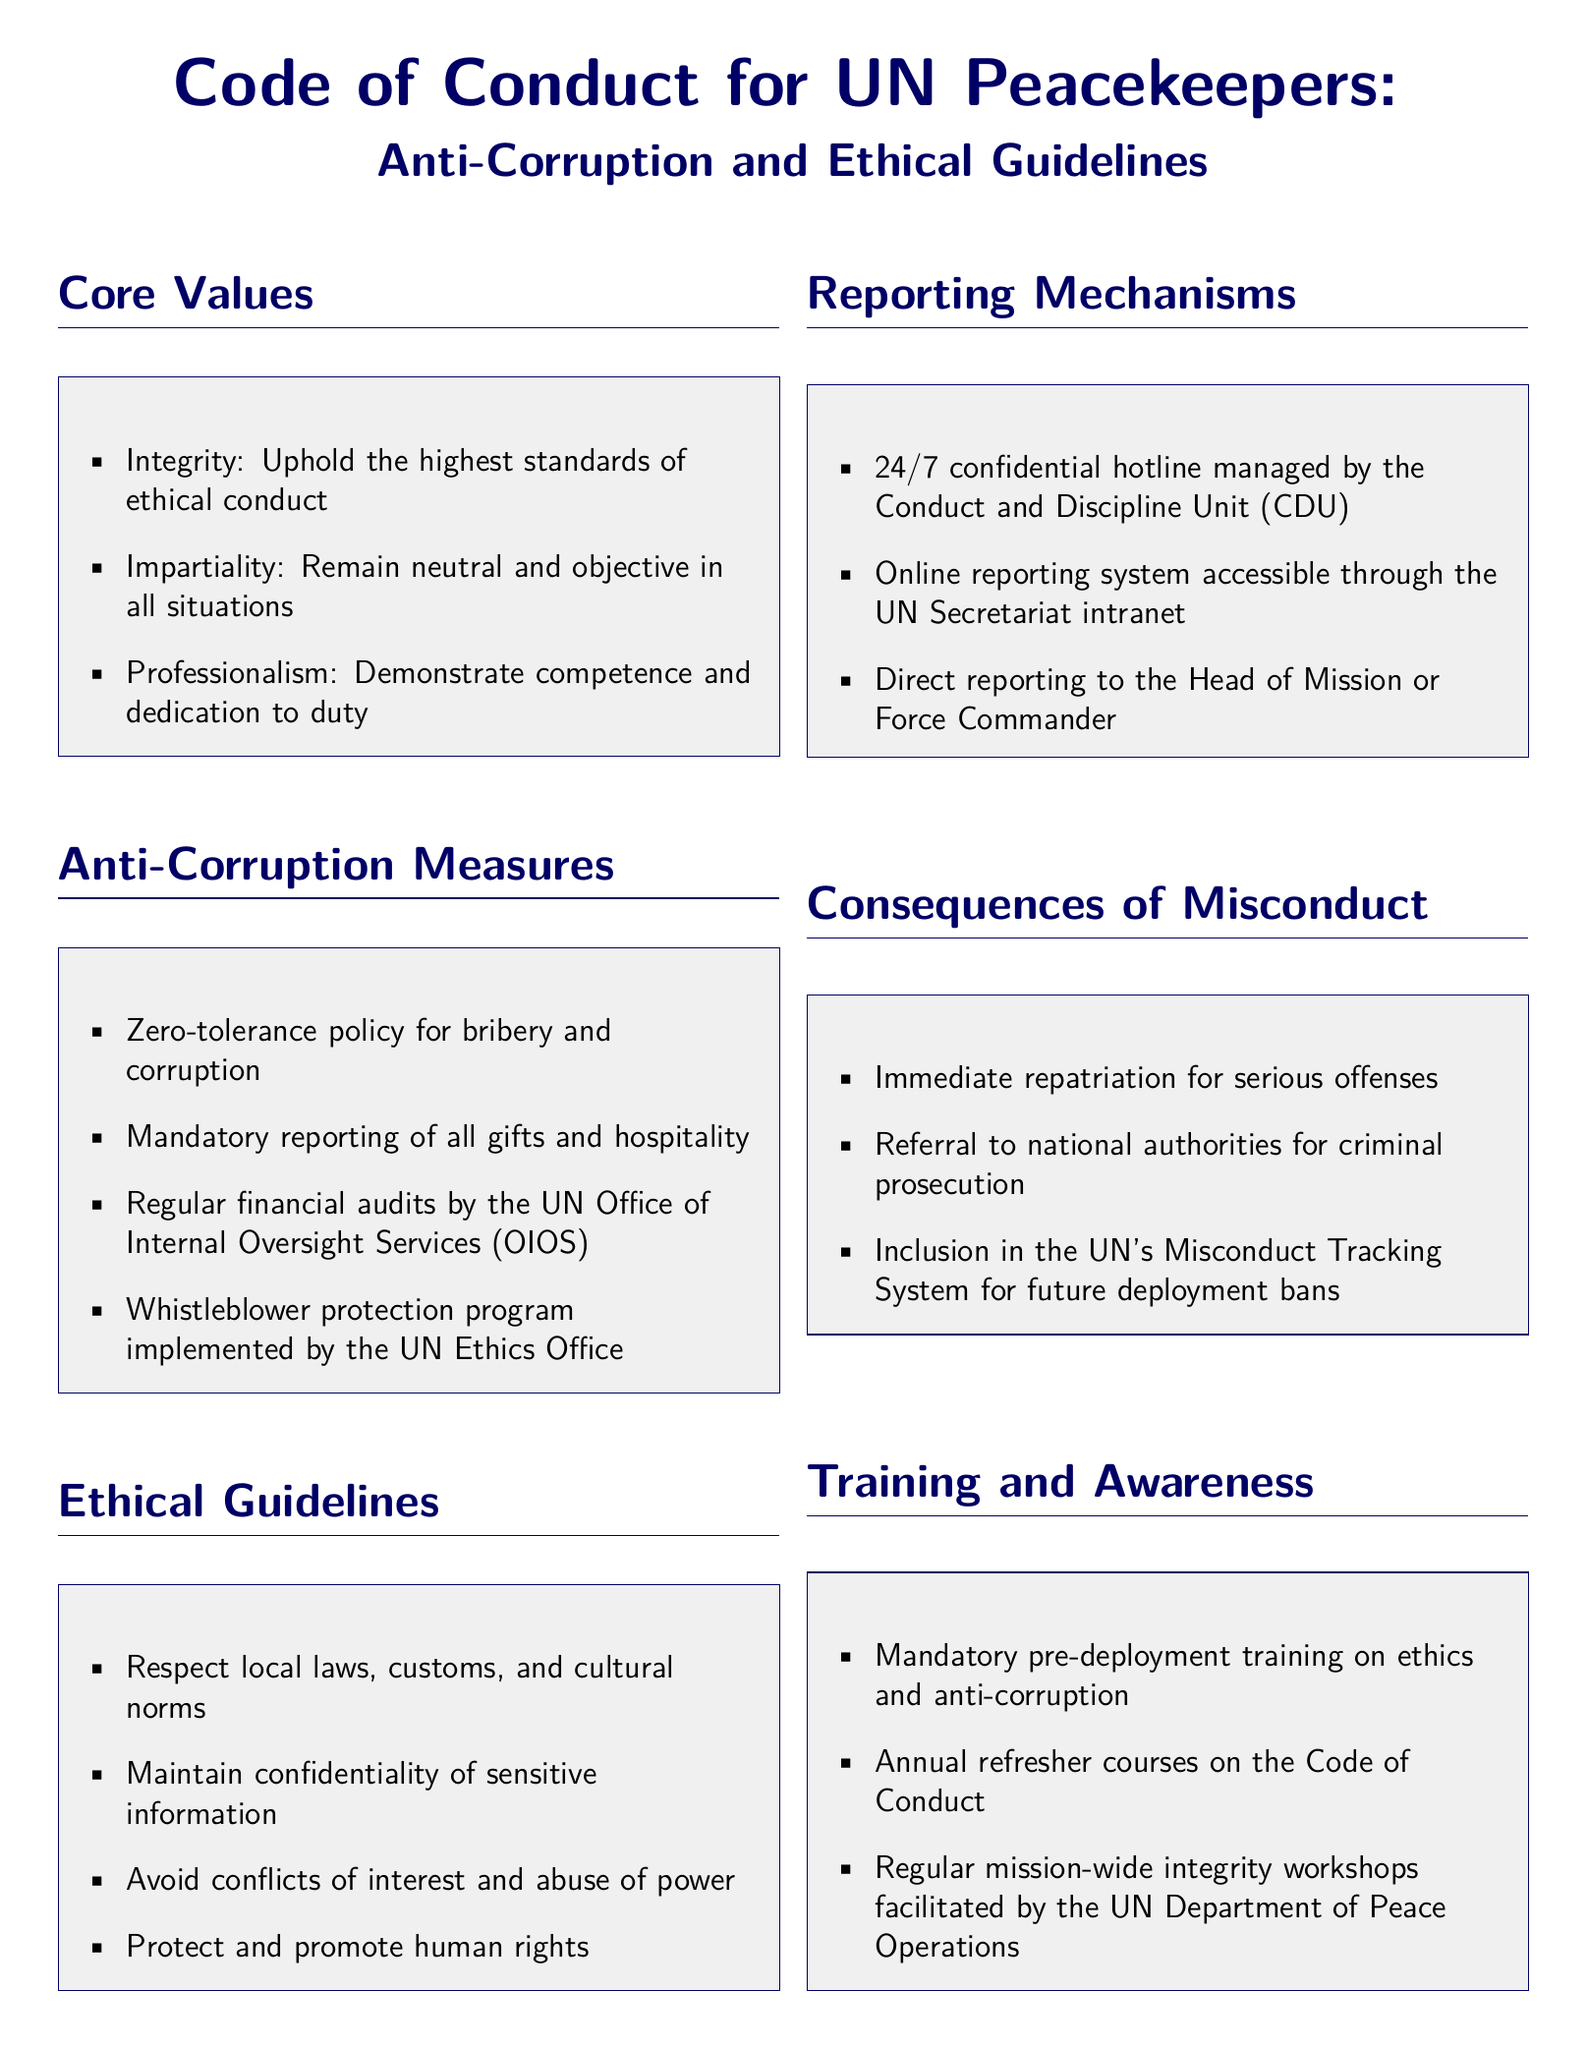What are the core values of peacekeepers? The core values listed include Integrity, Impartiality, and Professionalism.
Answer: Integrity, Impartiality, Professionalism What is the stance on bribery and corruption? The document states a zero-tolerance policy for bribery and corruption.
Answer: Zero-tolerance What is one of the reporting mechanisms available? A 24/7 confidential hotline managed by the Conduct and Discipline Unit is one reporting mechanism mentioned.
Answer: Confidential hotline What training is mandatory for peacekeepers before deployment? The document specifies mandatory pre-deployment training on ethics and anti-corruption.
Answer: Pre-deployment training What is the consequence for serious offenses? Immediate repatriation is one consequence for serious offenses mentioned in the document.
Answer: Immediate repatriation How often should peacekeepers undergo refresher courses on the Code of Conduct? Annual refresher courses on the Code of Conduct are required.
Answer: Annual Which entity conducts regular financial audits? The UN Office of Internal Oversight Services (OIOS) is responsible for regular financial audits.
Answer: UN Office of Internal Oversight Services What is a measure for protecting whistleblowers? The document mentions a whistleblower protection program implemented by the UN Ethics Office.
Answer: Whistleblower protection program How can conflicts of interest be avoided according to ethical guidelines? The guidelines state that peacekeepers must avoid conflicts of interest and abuse of power.
Answer: Avoid conflicts of interest 